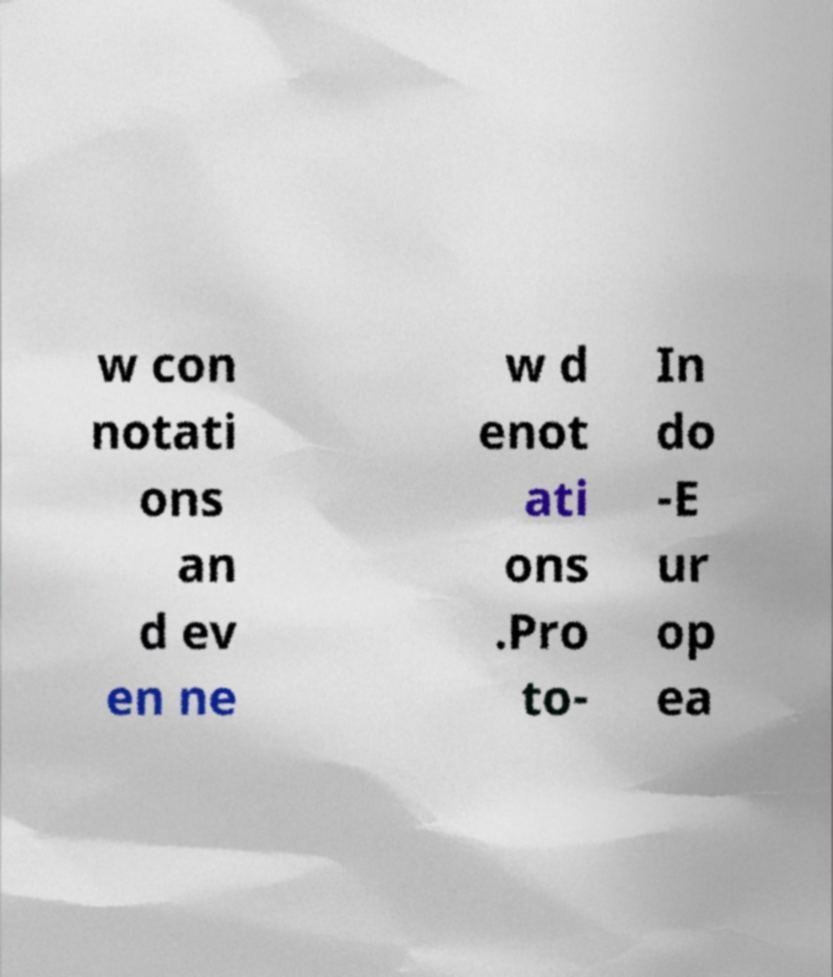What messages or text are displayed in this image? I need them in a readable, typed format. w con notati ons an d ev en ne w d enot ati ons .Pro to- In do -E ur op ea 